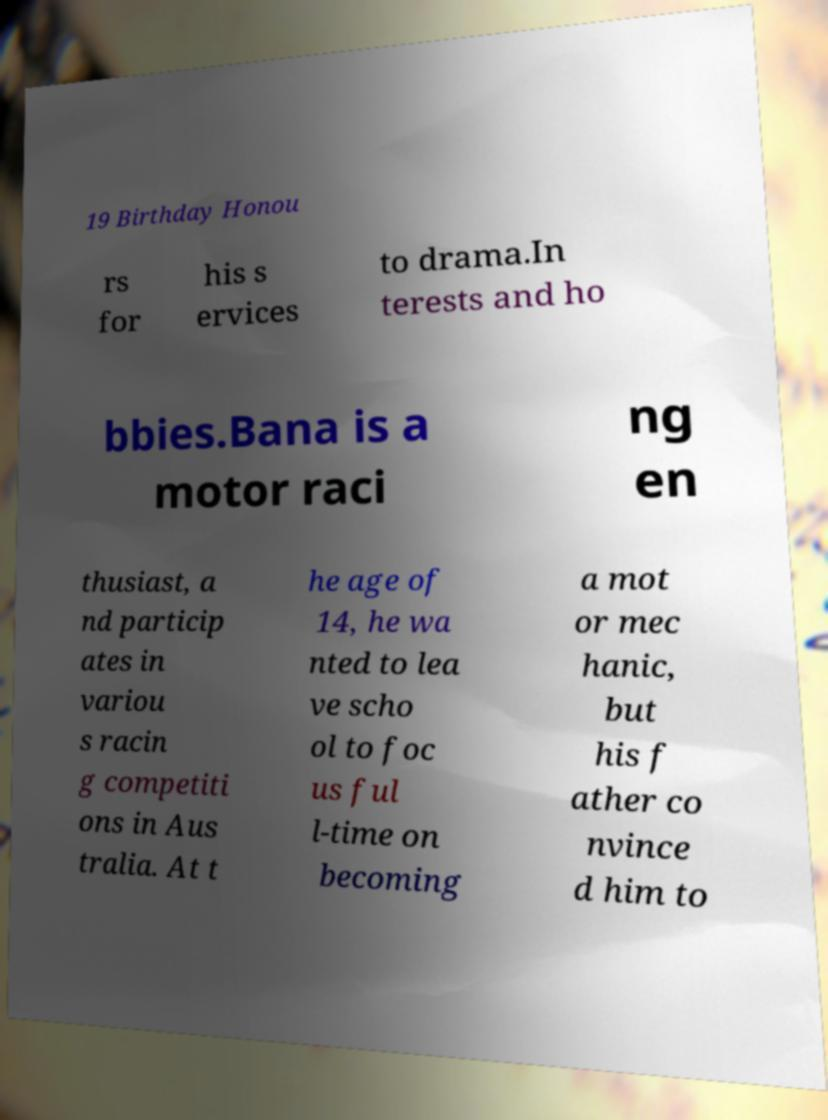Could you extract and type out the text from this image? 19 Birthday Honou rs for his s ervices to drama.In terests and ho bbies.Bana is a motor raci ng en thusiast, a nd particip ates in variou s racin g competiti ons in Aus tralia. At t he age of 14, he wa nted to lea ve scho ol to foc us ful l-time on becoming a mot or mec hanic, but his f ather co nvince d him to 